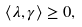Convert formula to latex. <formula><loc_0><loc_0><loc_500><loc_500>\langle \lambda , \gamma \rangle \geq 0 ,</formula> 